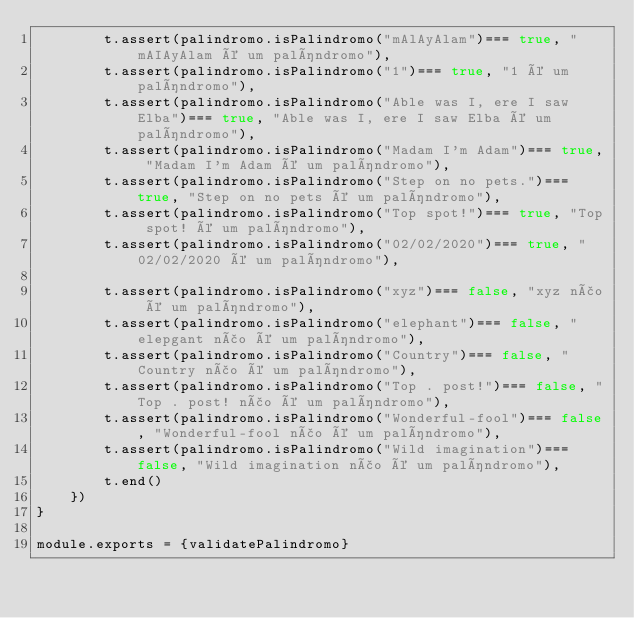<code> <loc_0><loc_0><loc_500><loc_500><_JavaScript_>        t.assert(palindromo.isPalindromo("mAlAyAlam")=== true, "mAIAyAlam é um palíndromo"),
        t.assert(palindromo.isPalindromo("1")=== true, "1 é um palíndromo"),
        t.assert(palindromo.isPalindromo("Able was I, ere I saw Elba")=== true, "Able was I, ere I saw Elba é um palíndromo"),
        t.assert(palindromo.isPalindromo("Madam I'm Adam")=== true, "Madam I'm Adam é um palíndromo"),
        t.assert(palindromo.isPalindromo("Step on no pets.")=== true, "Step on no pets é um palíndromo"),
        t.assert(palindromo.isPalindromo("Top spot!")=== true, "Top spot! é um palíndromo"),
        t.assert(palindromo.isPalindromo("02/02/2020")=== true, "02/02/2020 é um palíndromo"),

        t.assert(palindromo.isPalindromo("xyz")=== false, "xyz não é um palíndromo"),
        t.assert(palindromo.isPalindromo("elephant")=== false, "elepgant não é um palíndromo"),
        t.assert(palindromo.isPalindromo("Country")=== false, "Country não é um palíndromo"),
        t.assert(palindromo.isPalindromo("Top . post!")=== false, "Top . post! não é um palíndromo"),
        t.assert(palindromo.isPalindromo("Wonderful-fool")=== false, "Wonderful-fool não é um palíndromo"),
        t.assert(palindromo.isPalindromo("Wild imagination")=== false, "Wild imagination não é um palíndromo"),
        t.end()
    })
}

module.exports = {validatePalindromo}</code> 